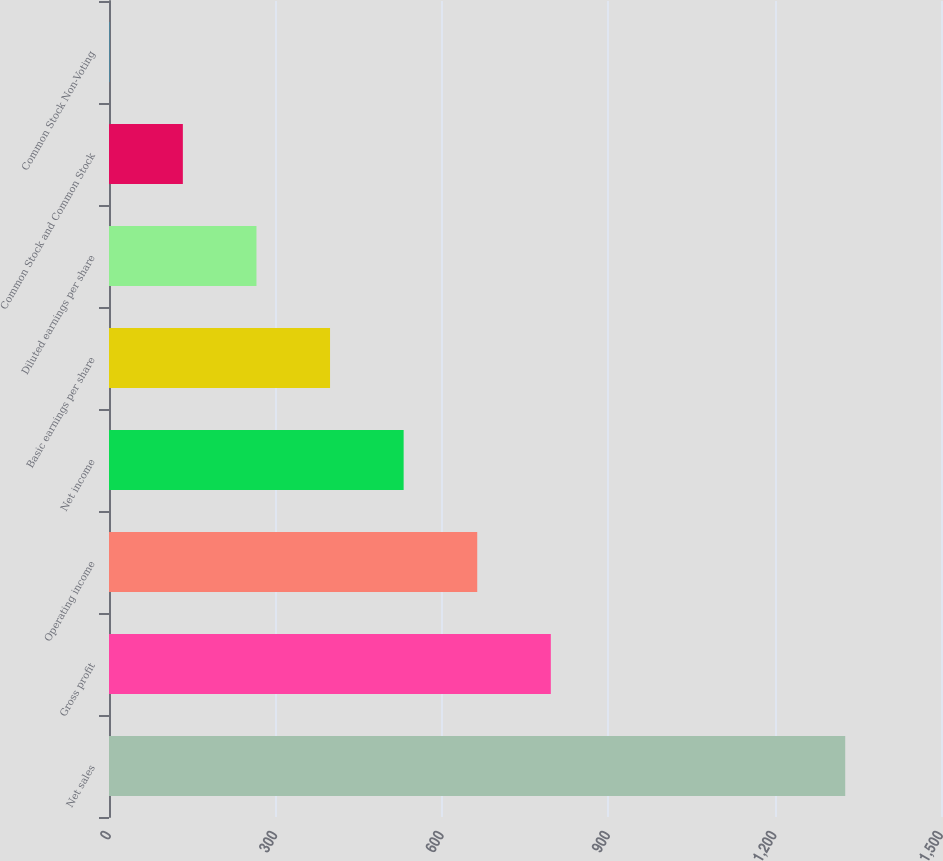Convert chart. <chart><loc_0><loc_0><loc_500><loc_500><bar_chart><fcel>Net sales<fcel>Gross profit<fcel>Operating income<fcel>Net income<fcel>Basic earnings per share<fcel>Diluted earnings per share<fcel>Common Stock and Common Stock<fcel>Common Stock Non-Voting<nl><fcel>1327.3<fcel>796.55<fcel>663.87<fcel>531.19<fcel>398.51<fcel>265.83<fcel>133.15<fcel>0.47<nl></chart> 